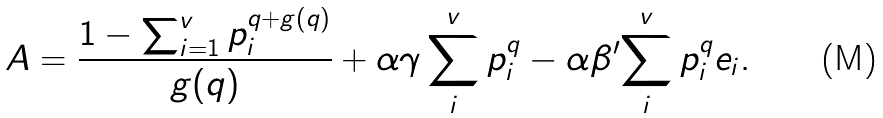<formula> <loc_0><loc_0><loc_500><loc_500>A = \frac { 1 - \sum _ { i = 1 } ^ { v } p _ { i } ^ { q + g ( q ) } } { g ( q ) } + \alpha \gamma \sum _ { i } ^ { v } p _ { i } ^ { q } - \alpha \beta ^ { \prime } { \sum _ { i } ^ { v } p _ { i } ^ { q } e _ { i } } .</formula> 